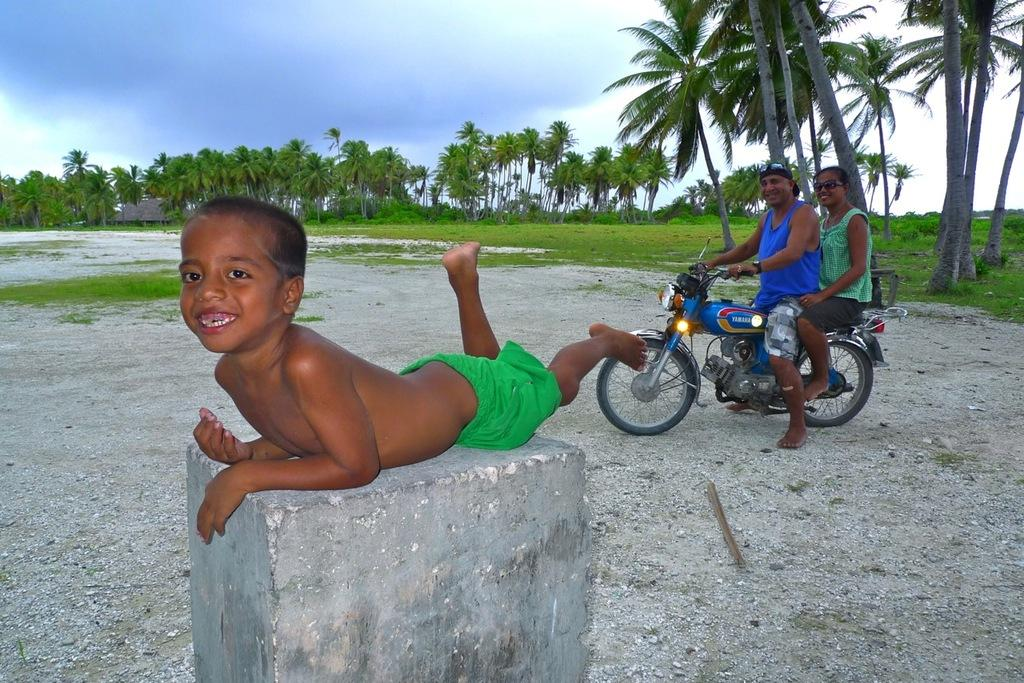How many people are on the bike in the image? There are two persons on a bike in the image. What can be said about the weight of the bike? The bike is described as light. What is the boy doing in the image? The boy is laying on a stone. What type of vegetation is present in the image? There is grass in the image. What other natural elements can be seen in the image? There are trees in the image. What is visible in the background of the image? The sky is visible in the background. What type of mark does the boy have on his forehead in the image? There is no mention of a mark on the boy's forehead in the image. What is the feeling of the grass in the image? The feeling of the grass cannot be determined from the image alone, as it is a visual medium. 